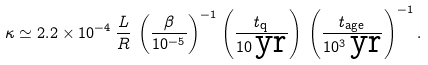<formula> <loc_0><loc_0><loc_500><loc_500>\kappa \simeq 2 . 2 \times 1 0 ^ { - 4 } \, { \frac { L } { R } } \, \left ( { \frac { \beta } { 1 0 ^ { - 5 } } } \right ) ^ { - 1 } \left ( { \frac { t _ { \text {q} } } { 1 0 \, \text {yr} } } \right ) \, \left ( { \frac { t _ { \text {age} } } { 1 0 ^ { 3 } \, \text {yr} } } \right ) ^ { - 1 } .</formula> 